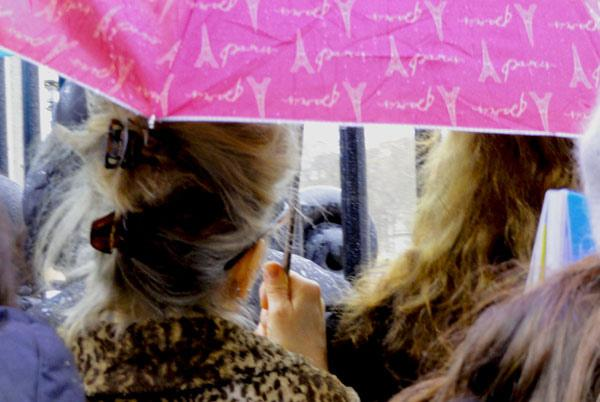What do the clips on the woman's head do for her? hold hair 